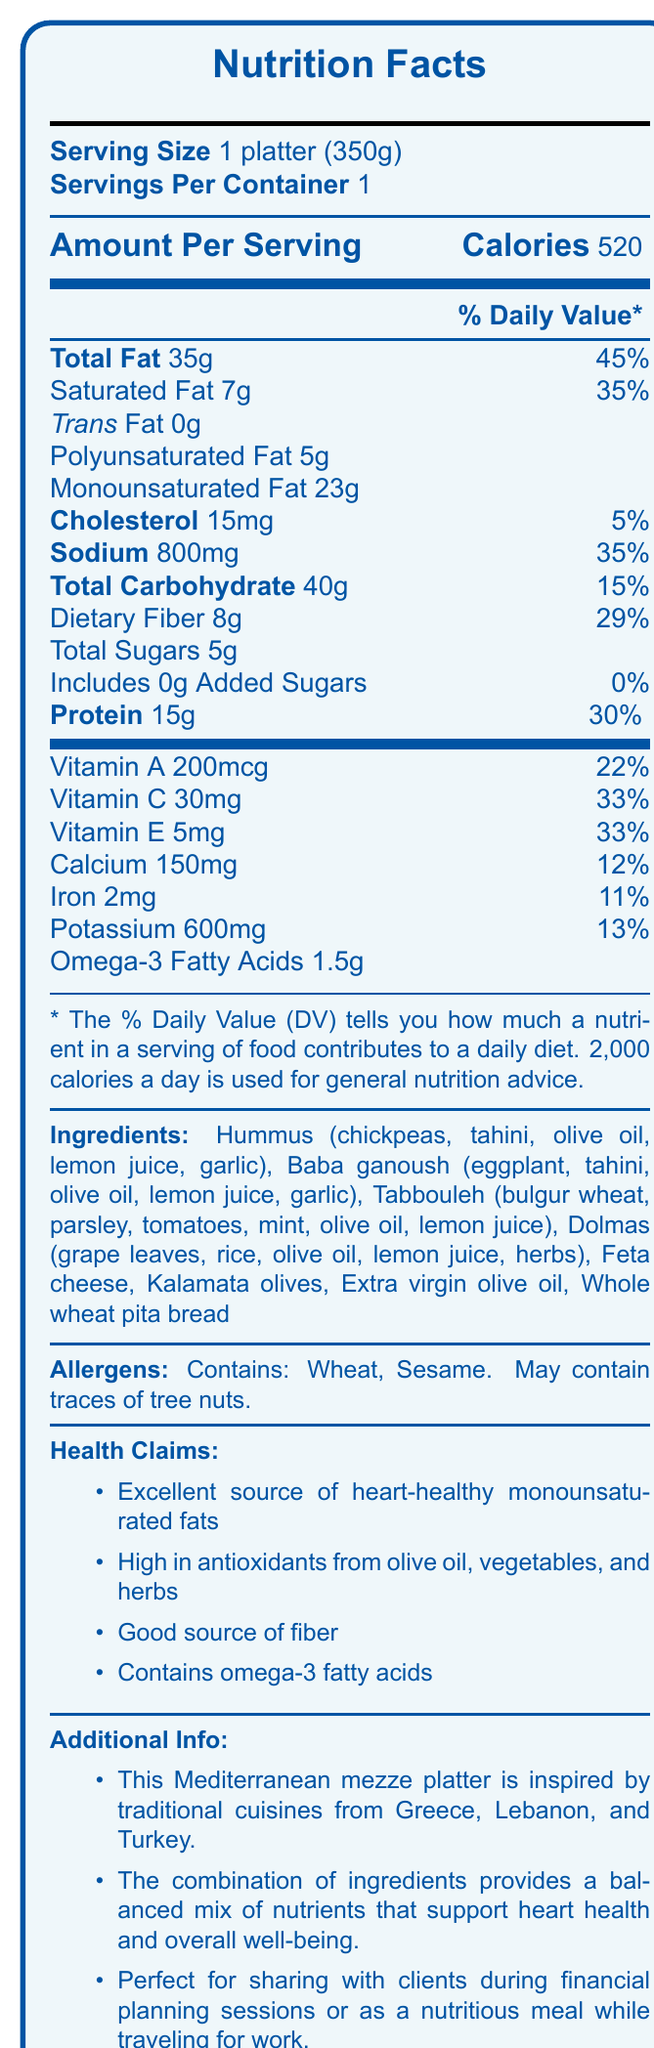what is the serving size of the platter? The serving size is clearly stated at the top of the nutrition facts section as "Serving Size 1 platter (350g)".
Answer: 1 platter (350g) how many calories are in one serving? The number of calories per serving is listed next to "Calories" in the large, bold font.
Answer: 520 what is the total fat content per serving? The total fat content is listed directly under "Total Fat" as "35g".
Answer: 35g what percentage of the daily value of sodium does this platter provide? The percentage daily value is listed next to "Sodium" as "35%".
Answer: 35% how much dietary fiber is in the platter? The dietary fiber content is listed under "Total Carbohydrate" as "Dietary Fiber 8g".
Answer: 8g does the platter contain any trans fat? The trans fat content is stated as "0g" directly under the saturated fat content.
Answer: No which ingredient is NOT listed in the ingredients section? A. Hummus B. Baba ganoush C. Quinoa D. Tabbouleh The ingredients section lists Hummus, Baba ganoush, Tabbouleh, but does not mention Quinoa.
Answer: C. Quinoa which nutrient in the platter contributes 30% of the daily value? A. Total Fat B. Sodium C. Protein D. Dietary Fiber The protein content is listed as contributing 30% of the daily value.
Answer: C. Protein how many grams of monounsaturated fat are in the platter? The monounsaturated fat content is listed under "Total Fat" as "Monounsaturated Fat 23g".
Answer: 23g is this platter a good source of antioxidants? The health claim mentions that the platter is "High in antioxidants from olive oil, vegetables, and herbs".
Answer: Yes how many grams of added sugars are there in this platter? The added sugars content is listed under "Total Sugars" as "Includes 0g Added Sugars".
Answer: 0g does the platter contain any allergens? The allergens section states that the platter contains wheat and sesame and may contain traces of tree nuts.
Answer: Yes summarize the main idea of the document. The document provides comprehensive nutritional information and highlights the health benefits of the Mediterranean mezze platter, making it useful for informed dietary choices or sharing with clients in a professional setting.
Answer: The document contains the nutrition facts for a Mediterranean mezze platter, emphasizing its heart-healthy fats and antioxidants. It details the servings, calories, macronutrient content, and vitamins and minerals. Ingredients and allergens are also listed, alongside health claims and additional information about the platter's inspiration and uses. what traditional cuisines inspired this Mediterranean mezze platter? The additional information section mentions that the platter is inspired by traditional cuisines from Greece, Lebanon, and Turkey.
Answer: Greece, Lebanon, and Turkey how much cholesterol is in the platter? Cholesterol content is listed under "Cholesterol" as "15mg".
Answer: 15mg is this platter suitable for someone avoiding heart-healthy fats? The platter is explicitly mentioned as an "excellent source of heart-healthy monounsaturated fats" in the health claims section.
Answer: No what is the total carbohydrate content in the platter? The total carbohydrate content is listed as "Total Carbohydrate 40g".
Answer: 40g what is the source of omega-3 fatty acids in the platter? The document lists omega-3 fatty acids and their amount but does not specify the exact source.
Answer: Cannot be determined 